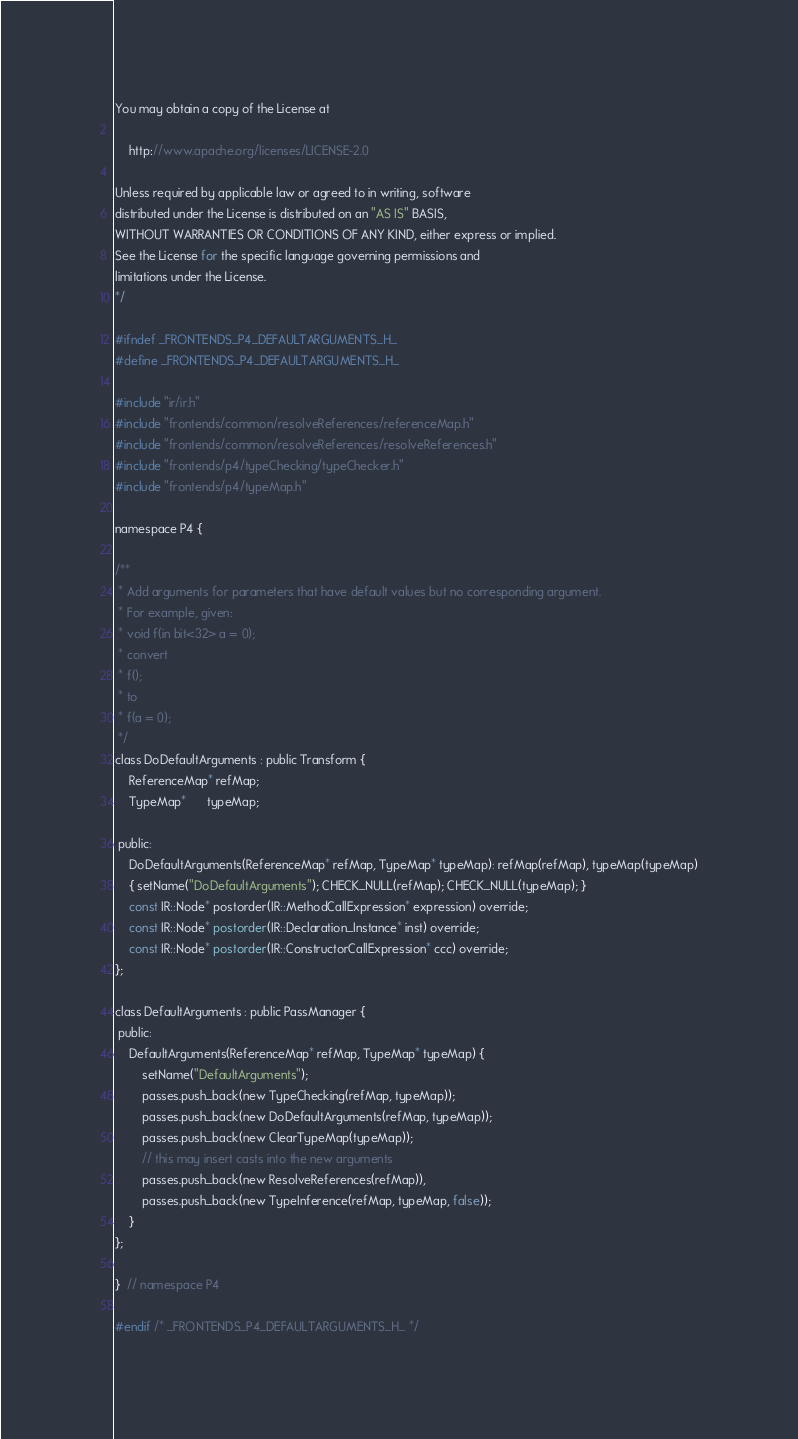Convert code to text. <code><loc_0><loc_0><loc_500><loc_500><_C_>You may obtain a copy of the License at

    http://www.apache.org/licenses/LICENSE-2.0

Unless required by applicable law or agreed to in writing, software
distributed under the License is distributed on an "AS IS" BASIS,
WITHOUT WARRANTIES OR CONDITIONS OF ANY KIND, either express or implied.
See the License for the specific language governing permissions and
limitations under the License.
*/

#ifndef _FRONTENDS_P4_DEFAULTARGUMENTS_H_
#define _FRONTENDS_P4_DEFAULTARGUMENTS_H_

#include "ir/ir.h"
#include "frontends/common/resolveReferences/referenceMap.h"
#include "frontends/common/resolveReferences/resolveReferences.h"
#include "frontends/p4/typeChecking/typeChecker.h"
#include "frontends/p4/typeMap.h"

namespace P4 {

/**
 * Add arguments for parameters that have default values but no corresponding argument.
 * For example, given:
 * void f(in bit<32> a = 0);
 * convert
 * f();
 * to
 * f(a = 0);
 */
class DoDefaultArguments : public Transform {
    ReferenceMap* refMap;
    TypeMap*      typeMap;

 public:
    DoDefaultArguments(ReferenceMap* refMap, TypeMap* typeMap): refMap(refMap), typeMap(typeMap)
    { setName("DoDefaultArguments"); CHECK_NULL(refMap); CHECK_NULL(typeMap); }
    const IR::Node* postorder(IR::MethodCallExpression* expression) override;
    const IR::Node* postorder(IR::Declaration_Instance* inst) override;
    const IR::Node* postorder(IR::ConstructorCallExpression* ccc) override;
};

class DefaultArguments : public PassManager {
 public:
    DefaultArguments(ReferenceMap* refMap, TypeMap* typeMap) {
        setName("DefaultArguments");
        passes.push_back(new TypeChecking(refMap, typeMap));
        passes.push_back(new DoDefaultArguments(refMap, typeMap));
        passes.push_back(new ClearTypeMap(typeMap));
        // this may insert casts into the new arguments
        passes.push_back(new ResolveReferences(refMap)),
        passes.push_back(new TypeInference(refMap, typeMap, false));
    }
};

}  // namespace P4

#endif /* _FRONTENDS_P4_DEFAULTARGUMENTS_H_ */
</code> 